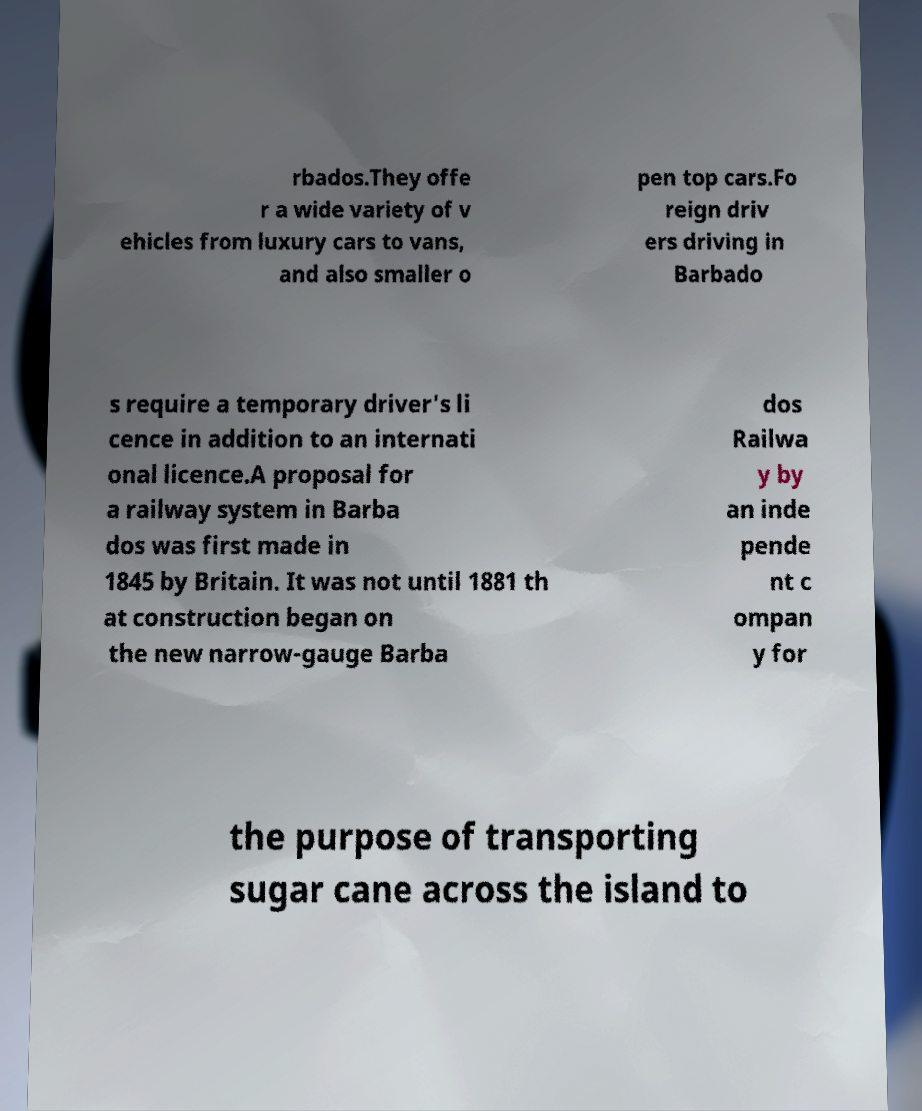Please read and relay the text visible in this image. What does it say? rbados.They offe r a wide variety of v ehicles from luxury cars to vans, and also smaller o pen top cars.Fo reign driv ers driving in Barbado s require a temporary driver's li cence in addition to an internati onal licence.A proposal for a railway system in Barba dos was first made in 1845 by Britain. It was not until 1881 th at construction began on the new narrow-gauge Barba dos Railwa y by an inde pende nt c ompan y for the purpose of transporting sugar cane across the island to 